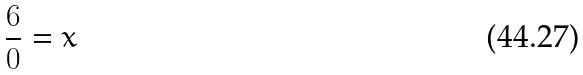Convert formula to latex. <formula><loc_0><loc_0><loc_500><loc_500>\frac { 6 } { 0 } = x</formula> 